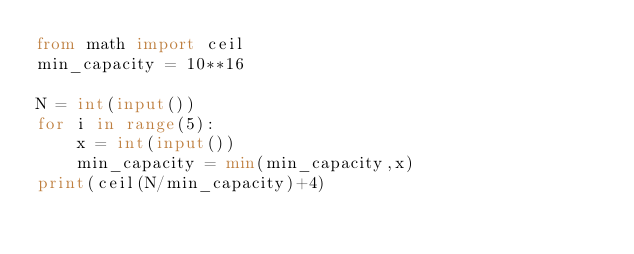Convert code to text. <code><loc_0><loc_0><loc_500><loc_500><_Python_>from math import ceil
min_capacity = 10**16

N = int(input())
for i in range(5):
    x = int(input())
    min_capacity = min(min_capacity,x)
print(ceil(N/min_capacity)+4)</code> 